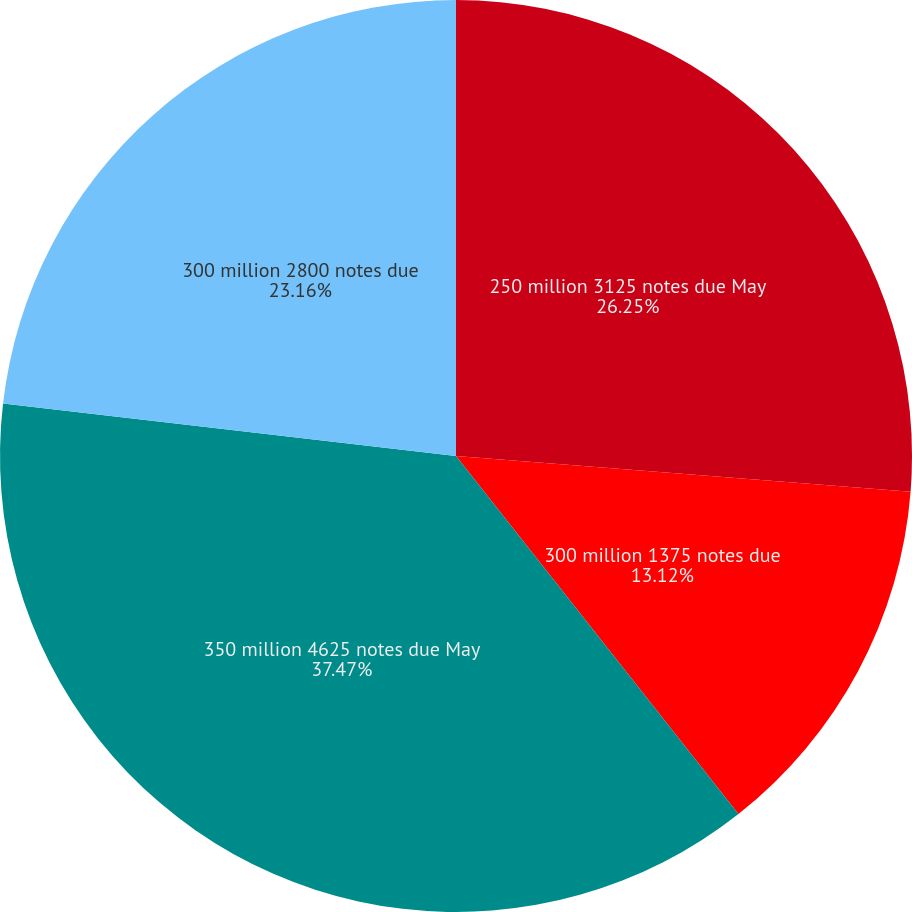Convert chart to OTSL. <chart><loc_0><loc_0><loc_500><loc_500><pie_chart><fcel>250 million 3125 notes due May<fcel>300 million 1375 notes due<fcel>350 million 4625 notes due May<fcel>300 million 2800 notes due<nl><fcel>26.25%<fcel>13.12%<fcel>37.47%<fcel>23.16%<nl></chart> 